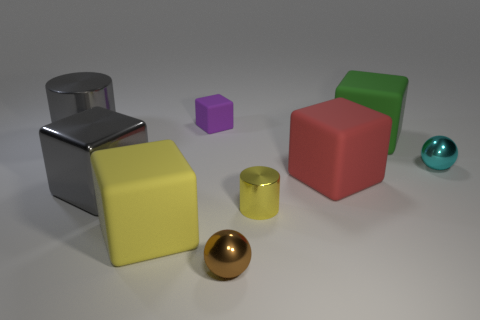Subtract all purple blocks. How many blocks are left? 4 Subtract all big yellow rubber blocks. How many blocks are left? 4 Subtract all brown blocks. Subtract all brown cylinders. How many blocks are left? 5 Add 1 big objects. How many objects exist? 10 Subtract all balls. How many objects are left? 7 Add 4 big metal objects. How many big metal objects are left? 6 Add 2 brown objects. How many brown objects exist? 3 Subtract 0 blue cylinders. How many objects are left? 9 Subtract all tiny rubber objects. Subtract all green objects. How many objects are left? 7 